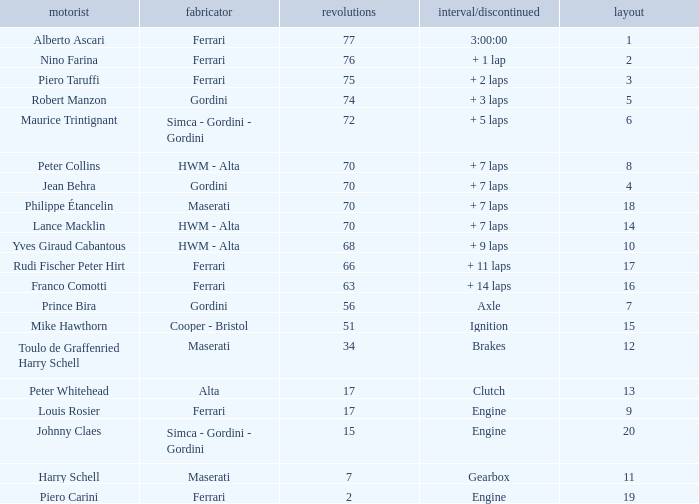Who drove the car with over 66 laps with a grid of 5? Robert Manzon. 